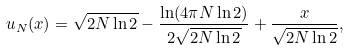<formula> <loc_0><loc_0><loc_500><loc_500>u _ { N } ( x ) = \sqrt { 2 N \ln 2 } - \frac { \ln ( 4 \pi N \ln 2 ) } { 2 \sqrt { 2 N \ln 2 } } + \frac { x } { \sqrt { 2 N \ln 2 } } ,</formula> 